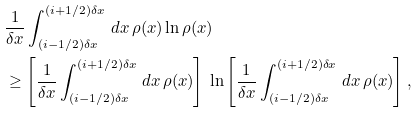<formula> <loc_0><loc_0><loc_500><loc_500>& \frac { 1 } { \delta x } \int _ { ( i - 1 / 2 ) \delta x } ^ { ( i + 1 / 2 ) \delta x } \, d x \, \rho ( x ) \ln \rho ( x ) \\ & \geq \left [ \frac { 1 } { \delta x } \int _ { ( i - 1 / 2 ) \delta x } ^ { ( i + 1 / 2 ) \delta x } \, d x \, \rho ( x ) \right ] \, \ln \left [ \frac { 1 } { \delta x } \int _ { ( i - 1 / 2 ) \delta x } ^ { ( i + 1 / 2 ) \delta x } \, d x \, \rho ( x ) \right ] ,</formula> 